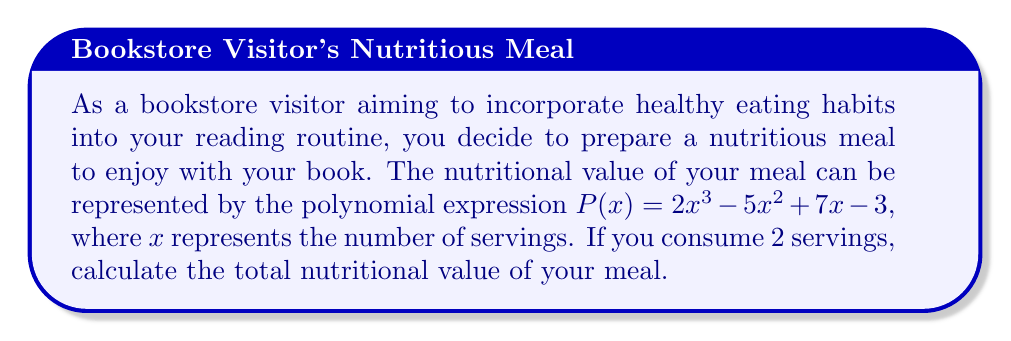Solve this math problem. To calculate the nutritional value of the meal for 2 servings, we need to evaluate the polynomial $P(x)$ at $x = 2$. Let's follow these steps:

1) We have $P(x) = 2x^3 - 5x^2 + 7x - 3$

2) Substitute $x = 2$ into the polynomial:
   $P(2) = 2(2)^3 - 5(2)^2 + 7(2) - 3$

3) Calculate each term:
   - $2(2)^3 = 2(8) = 16$
   - $5(2)^2 = 5(4) = 20$
   - $7(2) = 14$
   - $-3$ remains as is

4) Now our expression looks like this:
   $P(2) = 16 - 20 + 14 - 3$

5) Perform the arithmetic:
   $P(2) = 16 - 20 + 14 - 3 = 7$

Therefore, the total nutritional value of your meal for 2 servings is 7 units.
Answer: $7$ 